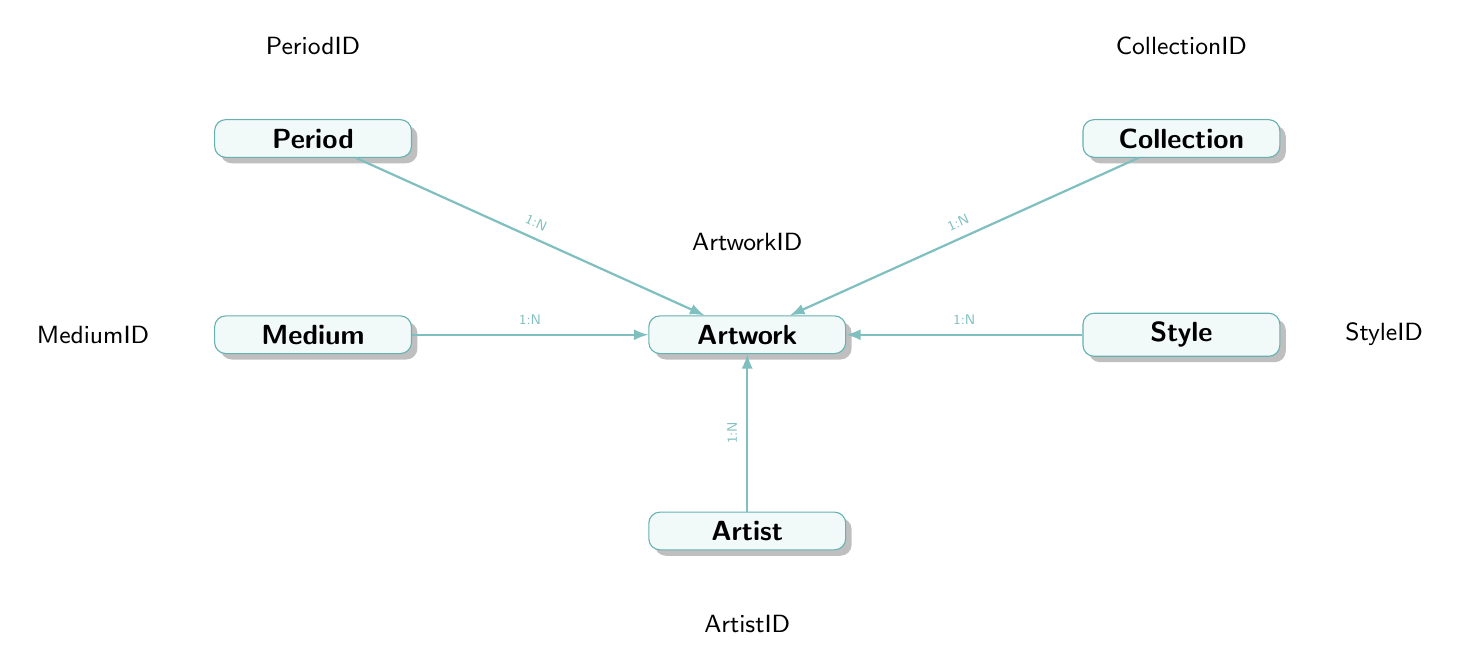What entity captures the relationship between artists and their artworks? The 'Artwork' entity is where the relationship is captured, as it includes the foreign key 'ArtistID' which links each artwork to its respective artist.
Answer: Artwork How many attributes does the 'Medium' entity have? The 'Medium' entity has three attributes: MediumID, Name, and Description.
Answer: 3 What is the foreign key that connects 'Artwork' to 'Style'? The foreign key that connects 'Artwork' to 'Style' is 'StyleID'.
Answer: StyleID Which relationship indicates that one artist can create multiple artworks? The relationship between 'Artist' and 'Artwork' indicates this, specifically a one-to-many relationship (1:N) from 'Artist' to 'Artwork'.
Answer: One-to-many What information is stored in the 'Collection' entity? The 'Collection' entity stores information regarding the collections of artworks, including CollectionID, Name, Description, and Owner.
Answer: CollectionID, Name, Description, Owner How many entities are present in this diagram? The diagram consists of six entities: Artwork, Artist, Medium, Style, Period, and Collection.
Answer: 6 What attribute within the 'Artwork' entity specifies the creation year? The attribute within the 'Artwork' entity that specifies the creation year is 'YearCreated'.
Answer: YearCreated Which entity has a direct connection to ‘Medium’ through a one-to-many relationship? The 'Artwork' entity has a direct connection to 'Medium' through a one-to-many relationship, as indicated in the relationships section of the diagram.
Answer: Artwork What is the type of relationship between 'Period' and 'Artwork'? The relationship type between 'Period' and 'Artwork' is one-to-many (1:N), suggesting that one period can include multiple artworks.
Answer: One-to-many 